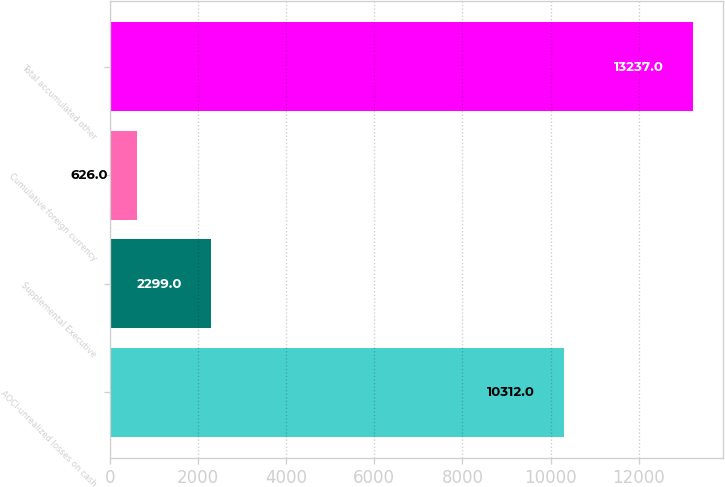Convert chart. <chart><loc_0><loc_0><loc_500><loc_500><bar_chart><fcel>AOCI-unrealized losses on cash<fcel>Supplemental Executive<fcel>Cumulative foreign currency<fcel>Total accumulated other<nl><fcel>10312<fcel>2299<fcel>626<fcel>13237<nl></chart> 